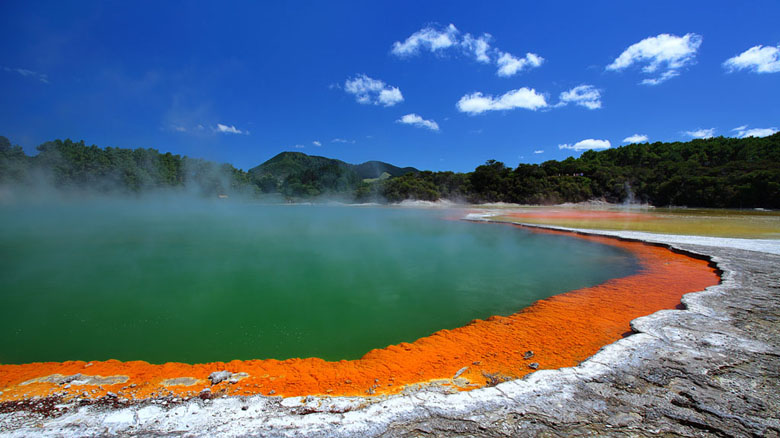How might scientists study this geothermal area? Scientists studying Wai-O-Tapu Thermal Wonderland use a multidisciplinary approach to understand its geothermal processes and ecological significance. They might start with geological surveys to map the underlying structures and measure thermal gradients. By sharegpt4v/sampling and analyzing water from the hot springs, mud pools, and geysers, scientists can identify the mineral content and understand the chemical interactions occurring below the surface.

Biologists would be interested in the microorganisms that thrive in such extreme conditions. These thermophiles can offer insights into extremophiles and potential applications in biotechnology. Environmental scientists might monitor the ecosystem’s health and assess any impacts of geothermal activity on the surrounding flora and fauna.

Advanced techniques such as remote sensing, drone photography, and geophysical sensors could provide continuous monitoring of the area's geothermal activity, helping predict changes and understand the dynamics of volcanic and geothermal systems. Collaborative research efforts would likely involve geologists, chemists, biologists, and environmental scientists, making it a rich field of study with broad implications for understanding geothermal phenomena and Earth's processes. 